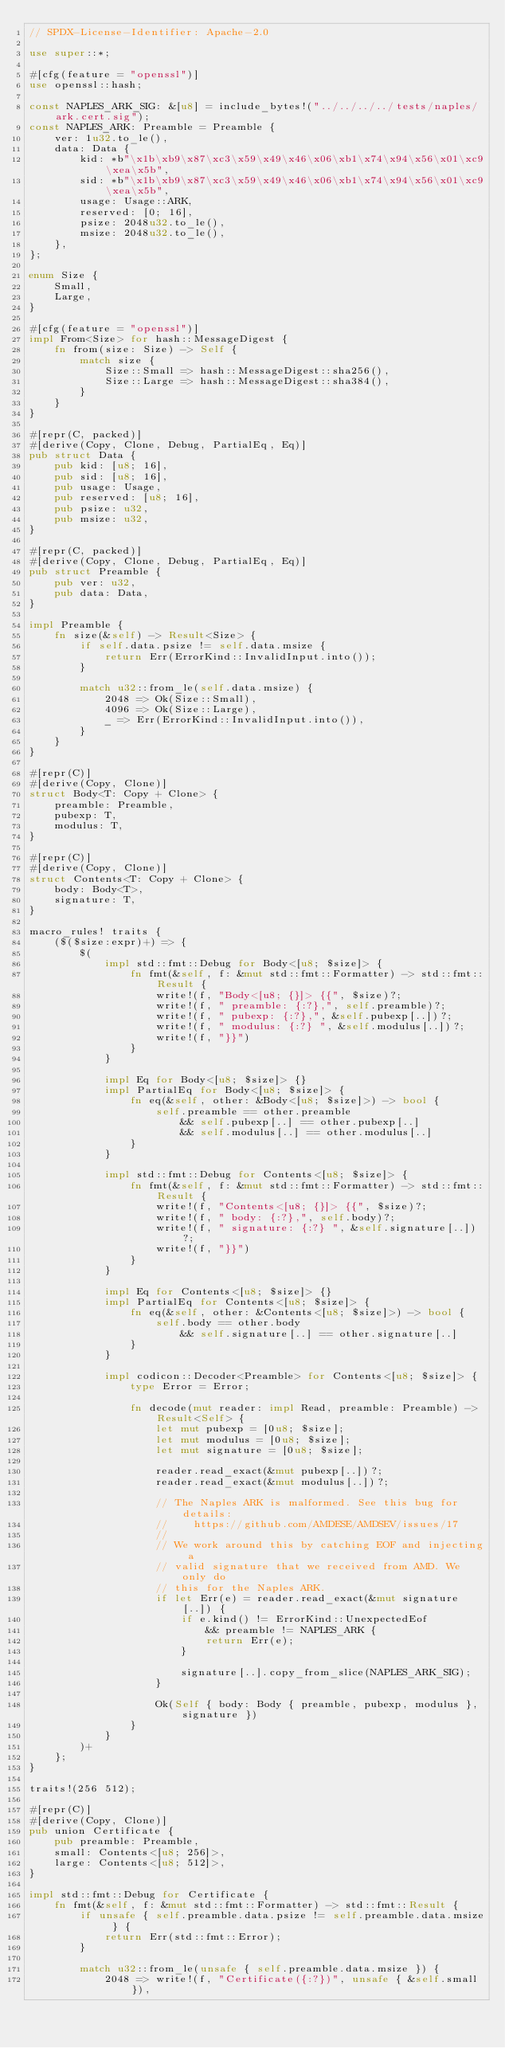<code> <loc_0><loc_0><loc_500><loc_500><_Rust_>// SPDX-License-Identifier: Apache-2.0

use super::*;

#[cfg(feature = "openssl")]
use openssl::hash;

const NAPLES_ARK_SIG: &[u8] = include_bytes!("../../../../tests/naples/ark.cert.sig");
const NAPLES_ARK: Preamble = Preamble {
    ver: 1u32.to_le(),
    data: Data {
        kid: *b"\x1b\xb9\x87\xc3\x59\x49\x46\x06\xb1\x74\x94\x56\x01\xc9\xea\x5b",
        sid: *b"\x1b\xb9\x87\xc3\x59\x49\x46\x06\xb1\x74\x94\x56\x01\xc9\xea\x5b",
        usage: Usage::ARK,
        reserved: [0; 16],
        psize: 2048u32.to_le(),
        msize: 2048u32.to_le(),
    },
};

enum Size {
    Small,
    Large,
}

#[cfg(feature = "openssl")]
impl From<Size> for hash::MessageDigest {
    fn from(size: Size) -> Self {
        match size {
            Size::Small => hash::MessageDigest::sha256(),
            Size::Large => hash::MessageDigest::sha384(),
        }
    }
}

#[repr(C, packed)]
#[derive(Copy, Clone, Debug, PartialEq, Eq)]
pub struct Data {
    pub kid: [u8; 16],
    pub sid: [u8; 16],
    pub usage: Usage,
    pub reserved: [u8; 16],
    pub psize: u32,
    pub msize: u32,
}

#[repr(C, packed)]
#[derive(Copy, Clone, Debug, PartialEq, Eq)]
pub struct Preamble {
    pub ver: u32,
    pub data: Data,
}

impl Preamble {
    fn size(&self) -> Result<Size> {
        if self.data.psize != self.data.msize {
            return Err(ErrorKind::InvalidInput.into());
        }

        match u32::from_le(self.data.msize) {
            2048 => Ok(Size::Small),
            4096 => Ok(Size::Large),
            _ => Err(ErrorKind::InvalidInput.into()),
        }
    }
}

#[repr(C)]
#[derive(Copy, Clone)]
struct Body<T: Copy + Clone> {
    preamble: Preamble,
    pubexp: T,
    modulus: T,
}

#[repr(C)]
#[derive(Copy, Clone)]
struct Contents<T: Copy + Clone> {
    body: Body<T>,
    signature: T,
}

macro_rules! traits {
    ($($size:expr)+) => {
        $(
            impl std::fmt::Debug for Body<[u8; $size]> {
                fn fmt(&self, f: &mut std::fmt::Formatter) -> std::fmt::Result {
                    write!(f, "Body<[u8; {}]> {{", $size)?;
                    write!(f, " preamble: {:?},", self.preamble)?;
                    write!(f, " pubexp: {:?},", &self.pubexp[..])?;
                    write!(f, " modulus: {:?} ", &self.modulus[..])?;
                    write!(f, "}}")
                }
            }

            impl Eq for Body<[u8; $size]> {}
            impl PartialEq for Body<[u8; $size]> {
                fn eq(&self, other: &Body<[u8; $size]>) -> bool {
                    self.preamble == other.preamble
                        && self.pubexp[..] == other.pubexp[..]
                        && self.modulus[..] == other.modulus[..]
                }
            }

            impl std::fmt::Debug for Contents<[u8; $size]> {
                fn fmt(&self, f: &mut std::fmt::Formatter) -> std::fmt::Result {
                    write!(f, "Contents<[u8; {}]> {{", $size)?;
                    write!(f, " body: {:?},", self.body)?;
                    write!(f, " signature: {:?} ", &self.signature[..])?;
                    write!(f, "}}")
                }
            }

            impl Eq for Contents<[u8; $size]> {}
            impl PartialEq for Contents<[u8; $size]> {
                fn eq(&self, other: &Contents<[u8; $size]>) -> bool {
                    self.body == other.body
                        && self.signature[..] == other.signature[..]
                }
            }

            impl codicon::Decoder<Preamble> for Contents<[u8; $size]> {
                type Error = Error;

                fn decode(mut reader: impl Read, preamble: Preamble) -> Result<Self> {
                    let mut pubexp = [0u8; $size];
                    let mut modulus = [0u8; $size];
                    let mut signature = [0u8; $size];

                    reader.read_exact(&mut pubexp[..])?;
                    reader.read_exact(&mut modulus[..])?;

                    // The Naples ARK is malformed. See this bug for details:
                    //    https://github.com/AMDESE/AMDSEV/issues/17
                    //
                    // We work around this by catching EOF and injecting a
                    // valid signature that we received from AMD. We only do
                    // this for the Naples ARK.
                    if let Err(e) = reader.read_exact(&mut signature[..]) {
                        if e.kind() != ErrorKind::UnexpectedEof
                            && preamble != NAPLES_ARK {
                            return Err(e);
                        }

                        signature[..].copy_from_slice(NAPLES_ARK_SIG);
                    }

                    Ok(Self { body: Body { preamble, pubexp, modulus }, signature })
                }
            }
        )+
    };
}

traits!(256 512);

#[repr(C)]
#[derive(Copy, Clone)]
pub union Certificate {
    pub preamble: Preamble,
    small: Contents<[u8; 256]>,
    large: Contents<[u8; 512]>,
}

impl std::fmt::Debug for Certificate {
    fn fmt(&self, f: &mut std::fmt::Formatter) -> std::fmt::Result {
        if unsafe { self.preamble.data.psize != self.preamble.data.msize } {
            return Err(std::fmt::Error);
        }

        match u32::from_le(unsafe { self.preamble.data.msize }) {
            2048 => write!(f, "Certificate({:?})", unsafe { &self.small }),</code> 